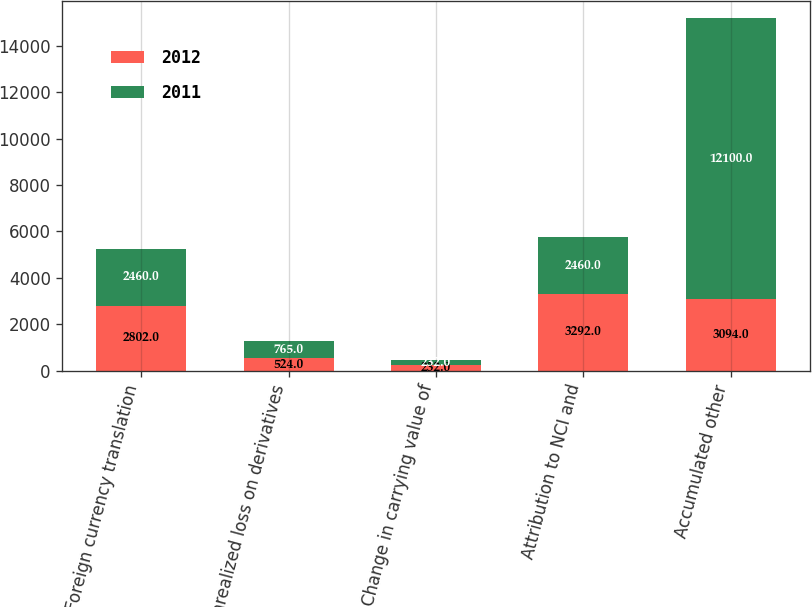Convert chart to OTSL. <chart><loc_0><loc_0><loc_500><loc_500><stacked_bar_chart><ecel><fcel>Foreign currency translation<fcel>Unrealized loss on derivatives<fcel>Change in carrying value of<fcel>Attribution to NCI and<fcel>Accumulated other<nl><fcel>2012<fcel>2802<fcel>524<fcel>232<fcel>3292<fcel>3094<nl><fcel>2011<fcel>2460<fcel>765<fcel>232<fcel>2460<fcel>12100<nl></chart> 